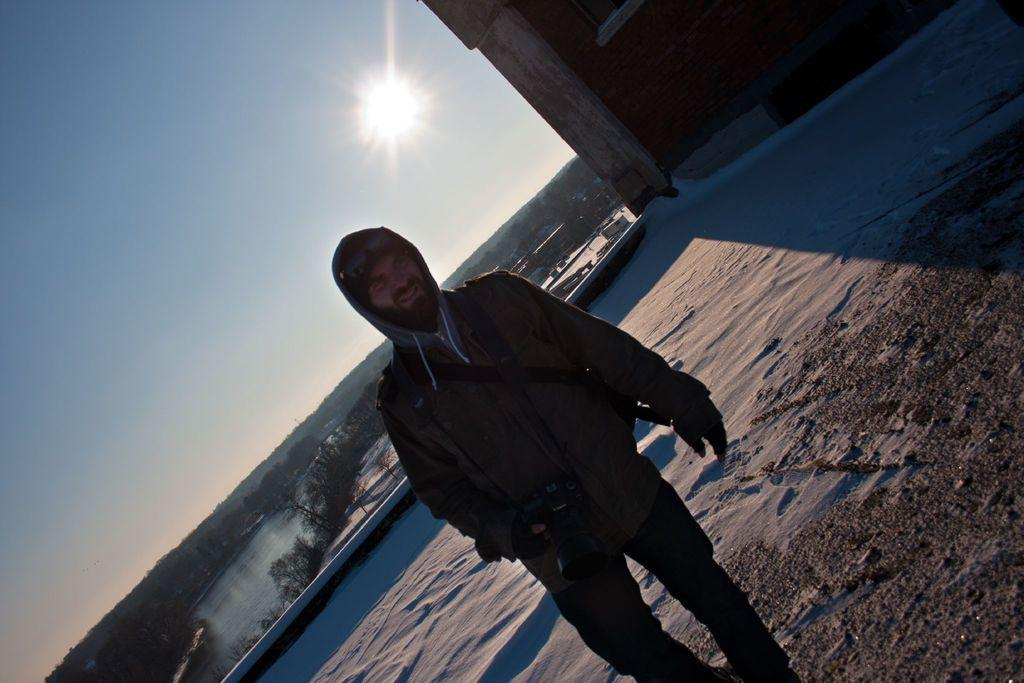What is the main subject in the image? There is a person standing in the image. What is located beside the person? There is a building beside the person. What can be seen behind the person? There is a river, trees, and houses behind the person. What is visible in the sky in the image? The sky is visible in the image, and the sun is present. What type of operation is being performed in the bedroom in the image? There is no bedroom or operation present in the image. 